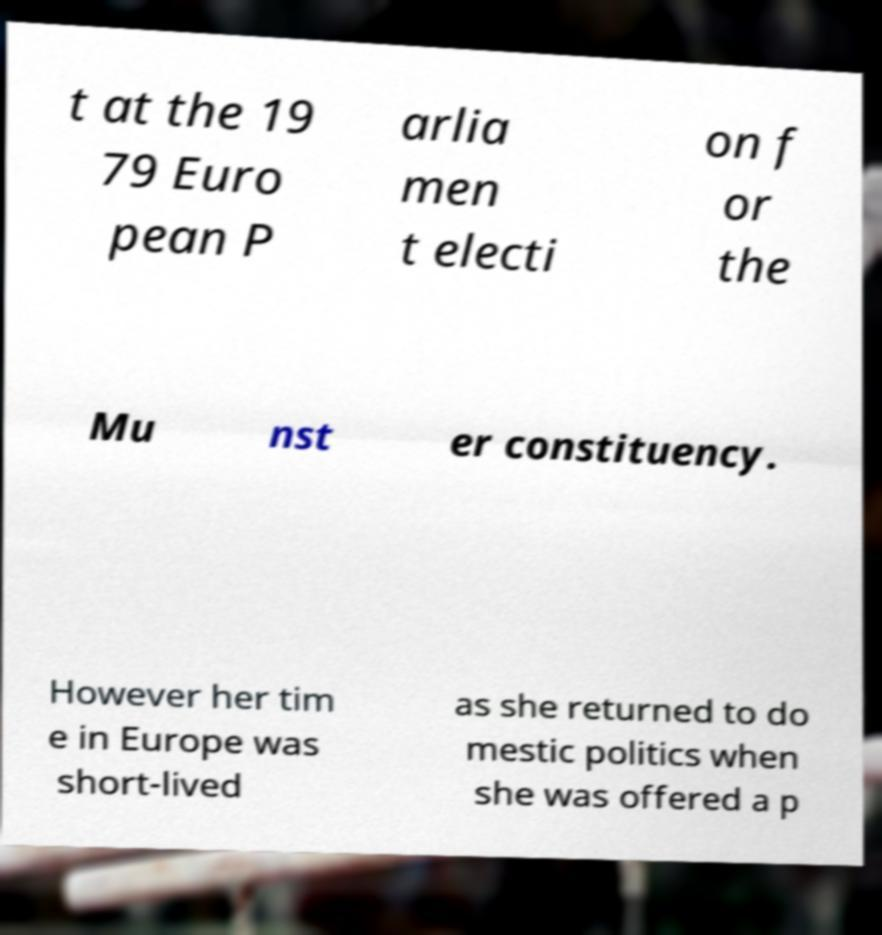Please identify and transcribe the text found in this image. t at the 19 79 Euro pean P arlia men t electi on f or the Mu nst er constituency. However her tim e in Europe was short-lived as she returned to do mestic politics when she was offered a p 